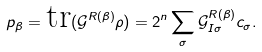<formula> <loc_0><loc_0><loc_500><loc_500>p _ { \beta } = \text {tr} ( \mathcal { G } ^ { R ( \beta ) } \rho ) = 2 ^ { n } \sum _ { \sigma } \mathcal { G } _ { I \sigma } ^ { R ( \beta ) } c _ { \sigma } .</formula> 